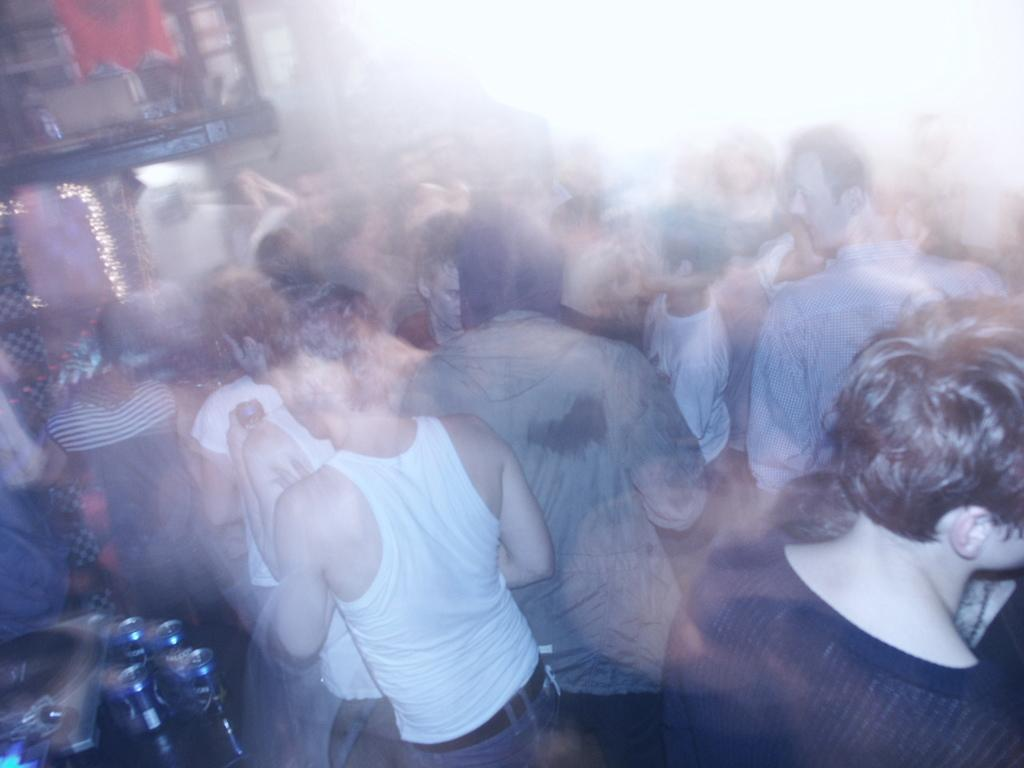What can be seen in the image? There are people standing in the image. Where are the people standing? The people are standing on the floor. What else is present in the image besides the people? There are beverage tins in the image. Where are the beverage tins located? The beverage tins are placed on a side table. What type of quince is being used as a decoration in the image? There is no quince present in the image; it features people standing on the floor and beverage tins on a side table. 